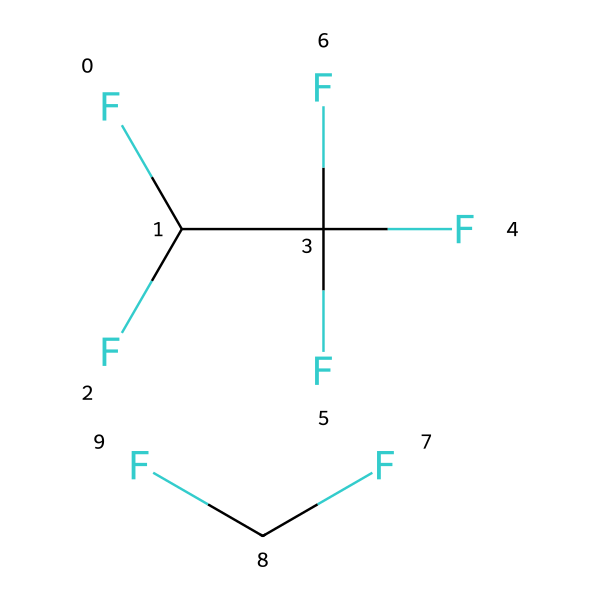What is the molecular formula of R-410A? The SMILES representation indicates there are two components. Each component can be analyzed: the first part, FC(F)C(F)(F)F, consists of 2 carbon atoms, 4 fluorine atoms, and 1 hydrogen atom, while the second part, FC(F), consists of 1 carbon atom, 2 fluorine atoms, and 1 hydrogen atom. Therefore, the total counts for R-410A are 3 carbon atoms (C), 6 fluorine atoms (F), and 2 hydrogen atoms (H), leading to the formula C3H2F6.
Answer: C3H2F6 How many carbon atoms are in R-410A? By examining the SMILES representation carefully, we can see that both segments contain carbon (C) atoms. The first part contributes 2 carbon atoms, and the second part contributes 1 carbon atom, for a total of 3.
Answer: 3 What type of bonds are present in R-410A? In the given SMILES, the presence of C-F and C-H indicates that R-410A contains single covalent bonds between carbon and fluorine, and carbon and hydrogen.
Answer: single covalent bonds Is R-410A a hydrofluorocarbon? The degree of hydrogen in the structure is limited, characterized by it having fluorine and carbon compounds without double or triple bonds. This conformational trait falls under the category of hydrofluorocarbons (HFCs).
Answer: Yes How many fluorine atoms are in R-410A? Counting the fluorine (F) atoms requires examining both parts of the SMILES. The first segment contains 4 fluorine atoms, while the second segment has 2 fluorine atoms, leading to a total of 6.
Answer: 6 What property of R-410A contributes to its effectiveness as a refrigerant? R-410A's high heat capacity, indicated by its molecular composition and the presence of multiple fluorine atoms, allows it to absorb and transfer heat efficiently, which is critical for refrigerant performance.
Answer: high heat capacity 